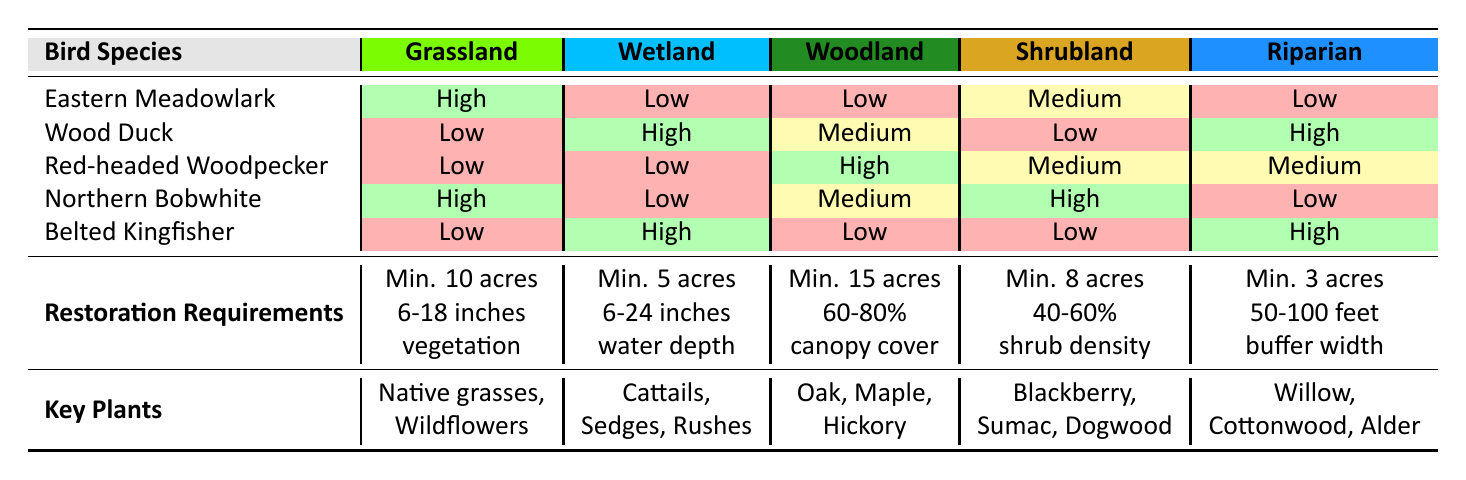What is the suitability level of the Eastern Meadowlark in Wetland habitat? The Wetland column for the Eastern Meadowlark shows "Low," indicating that this bird species is not well suited for Wetland habitat.
Answer: Low Which bird species has the highest suitability for Woodland habitat? According to the Woodland column, the Red-headed Woodpecker has "High" suitability, which is the highest among all species listed for that habitat type.
Answer: Red-headed Woodpecker Is the Northern Bobwhite suitable for Riparian habitat? The Riparian column for Northern Bobwhite indicates "Low," meaning this species is not suitable for Riparian habitat.
Answer: No What is the minimum area required for Shrubland restoration? The restoration requirements for Shrubland state a minimum area of 8 acres is needed for effective restoration of this habitat type.
Answer: 8 acres Which bird species are suitable for high suitability in Wetland habitat? By checking the Wetland column, the Wood Duck and Belted Kingfisher both show "High" suitability for Wetland habitat.
Answer: Wood Duck, Belted Kingfisher How many bird species have "High" suitability in Grassland habitat? In the Grassland column, both the Eastern Meadowlark and Northern Bobwhite have "High" suitability. Hence, there are 2 species with high suitability in this habitat.
Answer: 2 Does the Woodland habitat require more key plants compared to Shrubland? The key plants for Woodland are Oak, Maple, and Hickory, totaling 3, while Shrubland has Blackberry, Sumac, and Dogwood, also totaling 3. Therefore, the number of key plants is equal.
Answer: No What is the average minimum area requirement across all habitat types? Summing the minimum areas: 10 acres (Grassland) + 5 acres (Wetland) + 15 acres (Woodland) + 8 acres (Shrubland) + 3 acres (Riparian) equals 41 acres. Divided by the number of habitats (5), 41/5 equals 8.2 acres on average.
Answer: 8.2 acres Which bird species has the lowest suitability in Grassland habitat? In the Grassland column, the Wood Duck, Red-headed Woodpecker, and Belted Kingfisher all show "Low" suitability, making them the least suitable species in that habitat type.
Answer: Wood Duck, Red-headed Woodpecker, Belted Kingfisher 